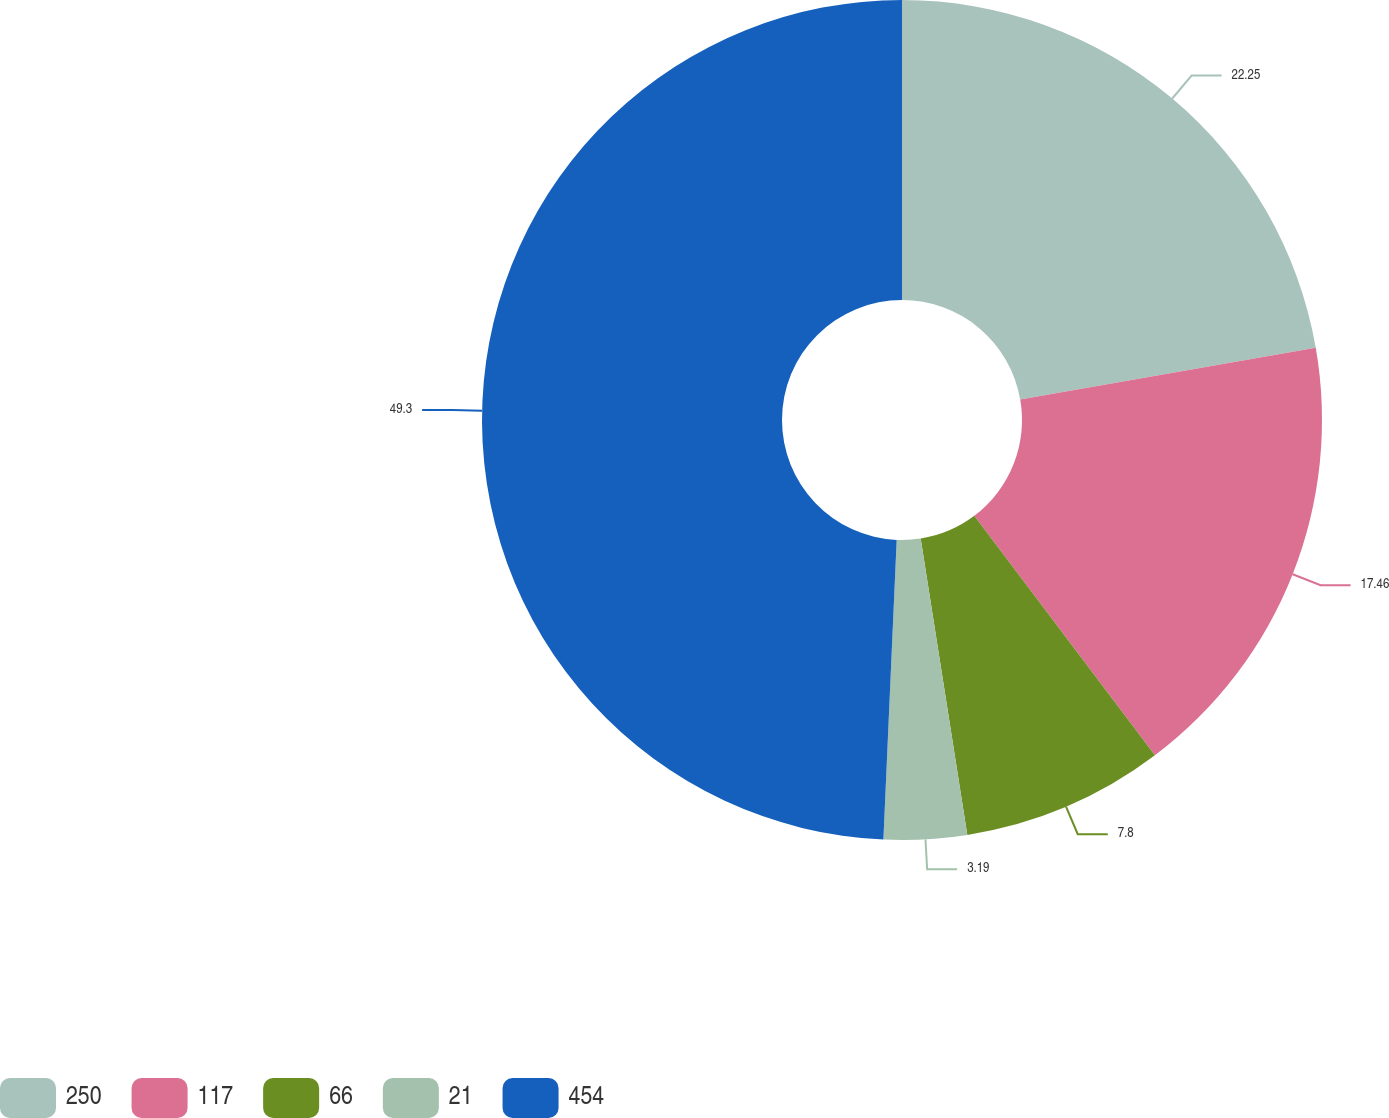Convert chart to OTSL. <chart><loc_0><loc_0><loc_500><loc_500><pie_chart><fcel>250<fcel>117<fcel>66<fcel>21<fcel>454<nl><fcel>22.25%<fcel>17.46%<fcel>7.8%<fcel>3.19%<fcel>49.29%<nl></chart> 